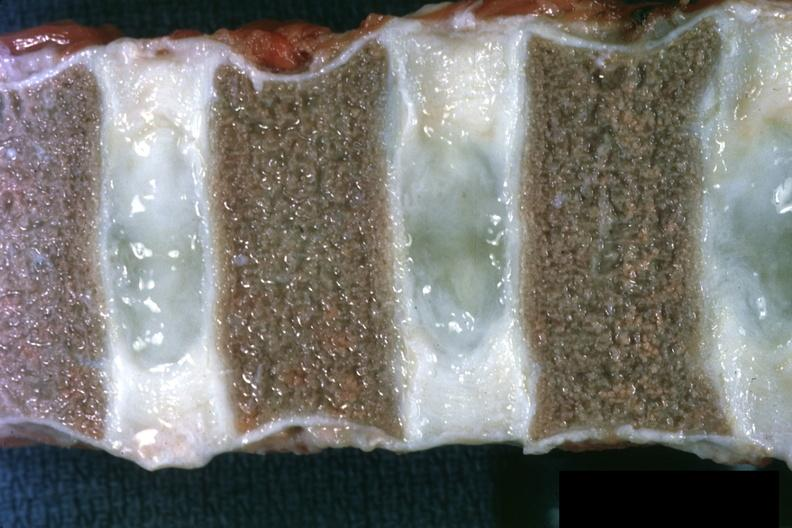s chronic myelogenous leukemia present?
Answer the question using a single word or phrase. Yes 